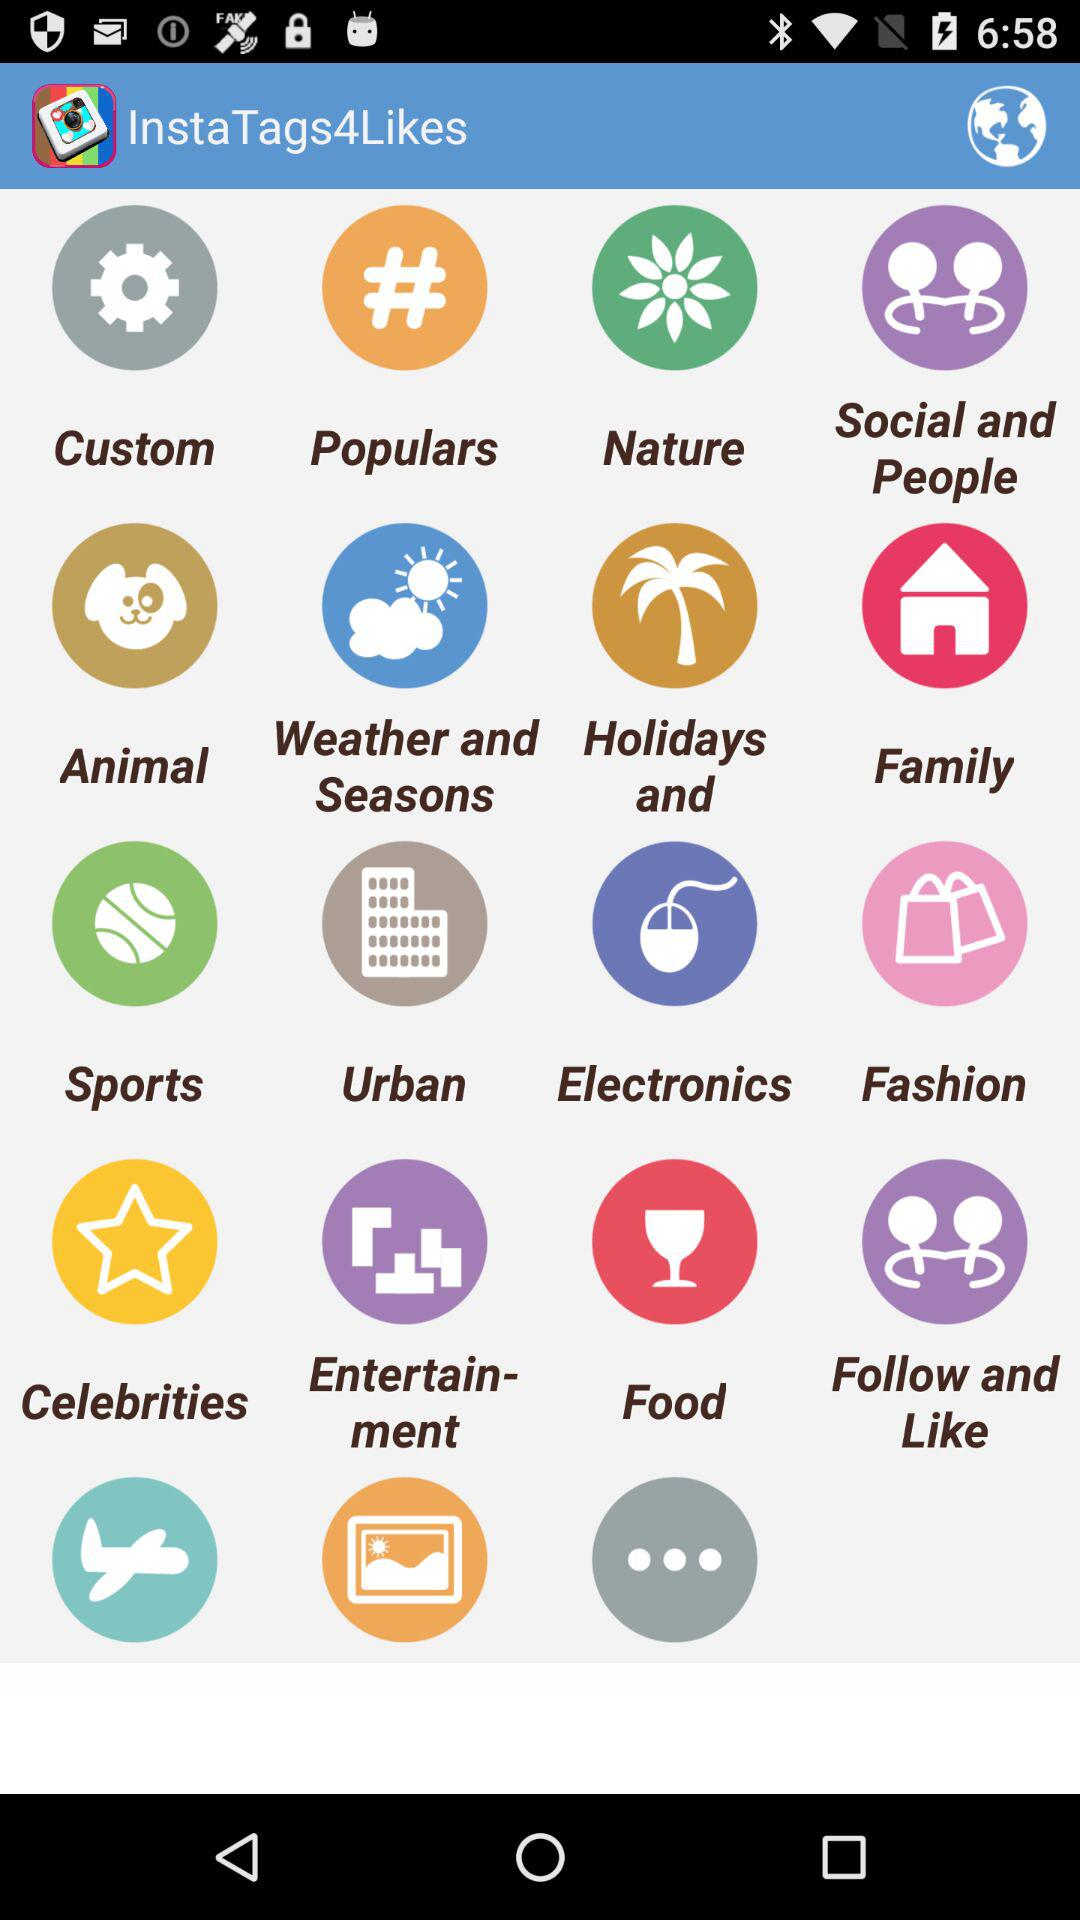What is the name of the application? The name of the application is "InstaTags4Likes". 